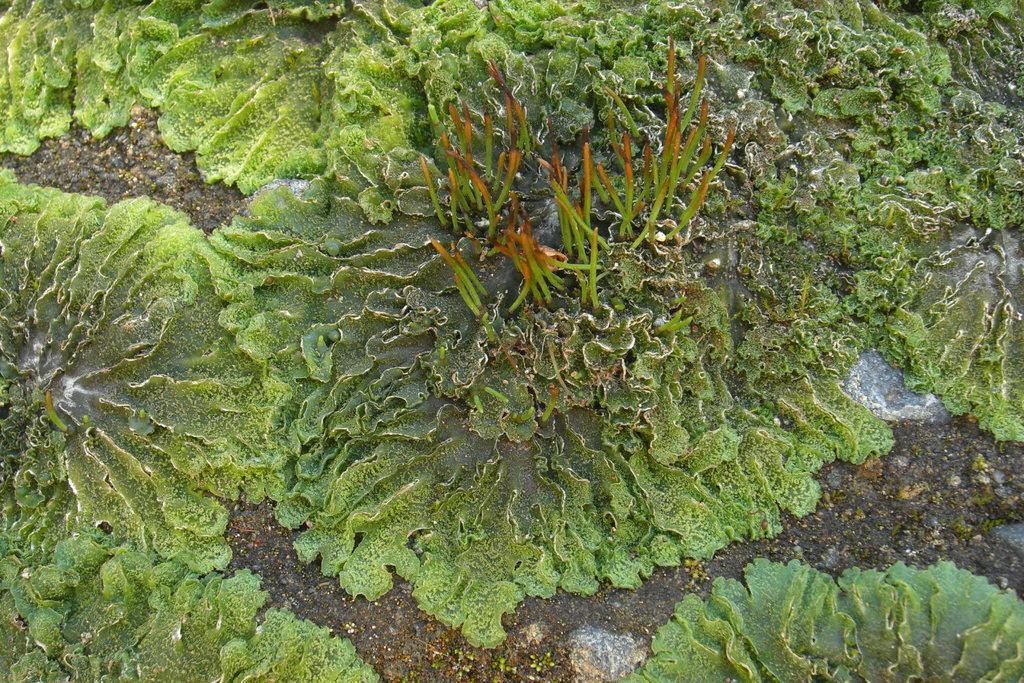What type of living organisms can be seen in the image? Plants can be seen in the image. Where are the plants located in the image? The plants are on the ground. How many marks do the boys give to the plants in the image? There are no marks or boys present in the image, as it only features plants on the ground. 